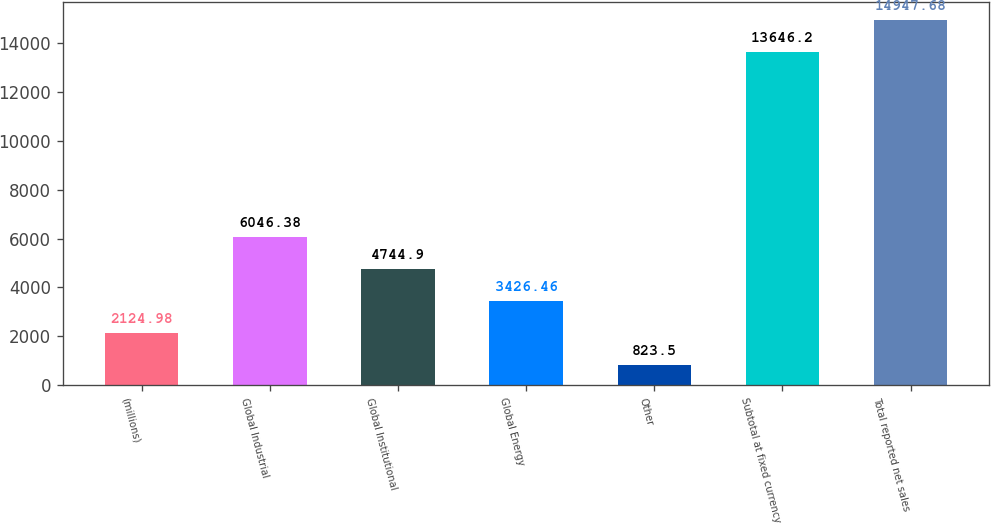Convert chart to OTSL. <chart><loc_0><loc_0><loc_500><loc_500><bar_chart><fcel>(millions)<fcel>Global Industrial<fcel>Global Institutional<fcel>Global Energy<fcel>Other<fcel>Subtotal at fixed currency<fcel>Total reported net sales<nl><fcel>2124.98<fcel>6046.38<fcel>4744.9<fcel>3426.46<fcel>823.5<fcel>13646.2<fcel>14947.7<nl></chart> 